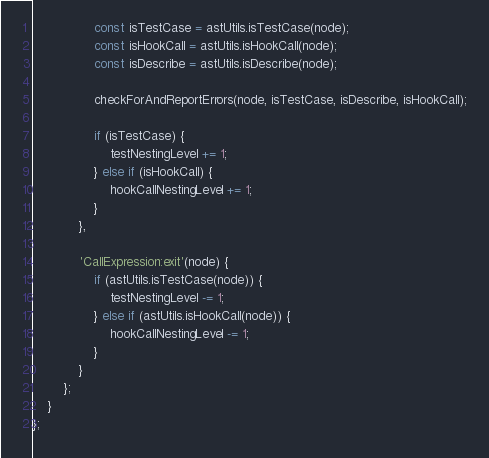Convert code to text. <code><loc_0><loc_0><loc_500><loc_500><_JavaScript_>                const isTestCase = astUtils.isTestCase(node);
                const isHookCall = astUtils.isHookCall(node);
                const isDescribe = astUtils.isDescribe(node);

                checkForAndReportErrors(node, isTestCase, isDescribe, isHookCall);

                if (isTestCase) {
                    testNestingLevel += 1;
                } else if (isHookCall) {
                    hookCallNestingLevel += 1;
                }
            },

            'CallExpression:exit'(node) {
                if (astUtils.isTestCase(node)) {
                    testNestingLevel -= 1;
                } else if (astUtils.isHookCall(node)) {
                    hookCallNestingLevel -= 1;
                }
            }
        };
    }
};
</code> 